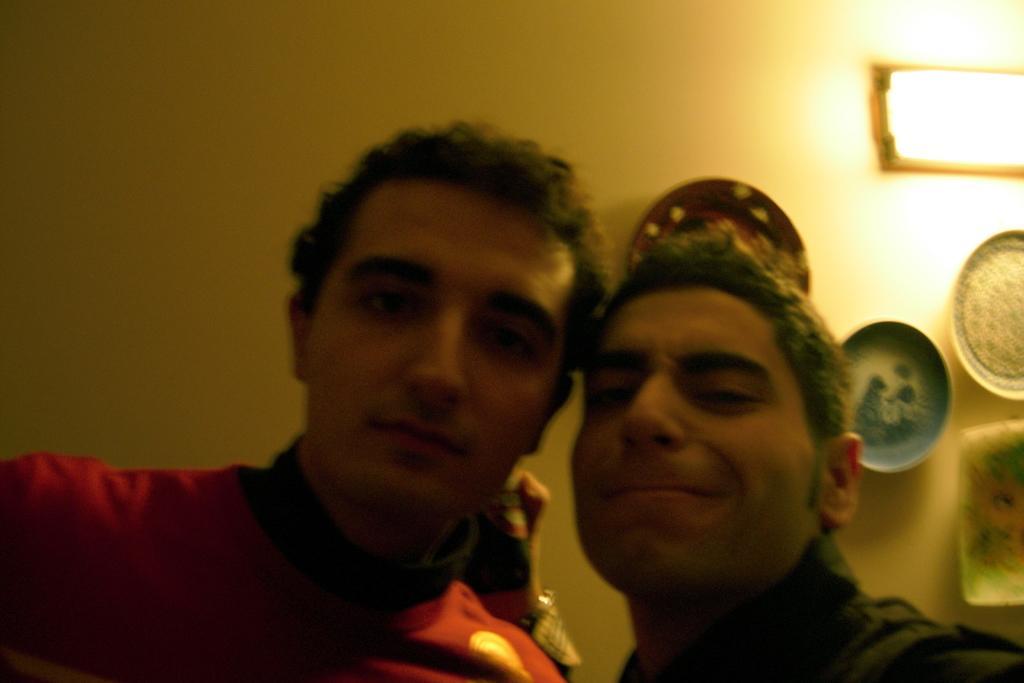In one or two sentences, can you explain what this image depicts? This picture seems to be clicked inside the room. In the foreground we can see the two persons seems to be standing. In the background we can see the wall and there are some items hanging on the wall. 